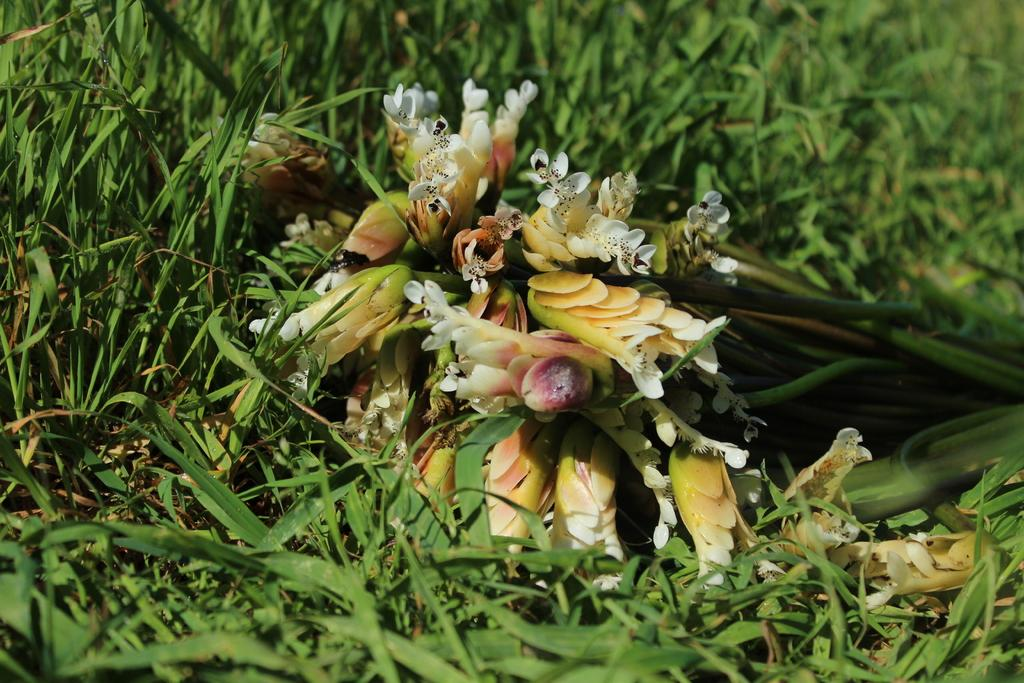What type of plants can be seen in the image? There are flowers in the image. Where are the flowers located? The flowers are on grassy land. Can you describe the position of the flowers in the image? The flowers are in the middle of the image. What type of jam is being spread on the lumber in the image? There is no jam or lumber present in the image; it features flowers on grassy land. 